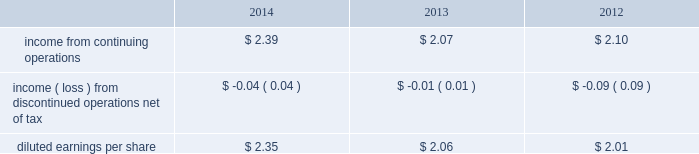From those currently anticipated and expressed in such forward-looking statements as a result of a number of factors , including those we discuss under 201crisk factors 201d and elsewhere in this form 10-k .
You should read 201crisk factors 201d and 201cforward-looking statements . 201d executive overview general american water works company , inc .
( herein referred to as 201camerican water 201d or the 201ccompany 201d ) is the largest investor-owned united states water and wastewater utility company , as measured both by operating revenues and population served .
Our approximately 6400 employees provide drinking water , wastewater and other water related services to an estimated 15 million people in 47 states and in one canadian province .
Our primary business involves the ownership of water and wastewater utilities that provide water and wastewater services to residential , commercial , industrial and other customers .
Our regulated businesses that provide these services are generally subject to economic regulation by state regulatory agencies in the states in which they operate .
The federal government and the states also regulate environmental , health and safety and water quality matters .
Our regulated businesses provide services in 16 states and serve approximately 3.2 million customers based on the number of active service connections to our water and wastewater networks .
We report the results of these businesses in our regulated businesses segment .
We also provide services that are not subject to economic regulation by state regulatory agencies .
We report the results of these businesses in our market-based operations segment .
In 2014 , we continued the execution of our strategic goals .
Our commitment to growth through investment in our regulated infrastructure and expansion of our regulated customer base and our market-based operations , combined with operational excellence led to continued improvement in regulated operating efficiency , improved performance of our market-based operations , and enabled us to provide increased value to our customers and investors .
During the year , we focused on growth , addressed regulatory lag , made more efficient use of capital and improved our regulated operation and maintenance ( 201co&m 201d ) efficiency ratio .
2014 financial results for the year ended december 31 , 2014 , we continued to increase net income , while making significant capital investment in our infrastructure and implementing operational efficiency improvements to keep customer rates affordable .
Highlights of our 2014 operating results compared to 2013 and 2012 include: .
Continuing operations income from continuing operations included 4 cents per diluted share of costs resulting from the freedom industries chemical spill in west virginia in 2014 and included 14 cents per diluted share in 2013 related to a tender offer .
Earnings from continuing operations , adjusted for these two items , increased 10% ( 10 % ) , or 22 cents per share , mainly due to favorable operating results from our regulated businesses segment due to higher revenues and lower operating expenses , partially offset by higher depreciation expenses .
Also contributing to the overall increase in income from continuing operations was lower interest expense in 2014 compared to the same period in 2013. .
By how much did diluted earnings per share increase from 2012 to 2014? 
Computations: ((2.35 - 2.01) / 2.01)
Answer: 0.16915. 